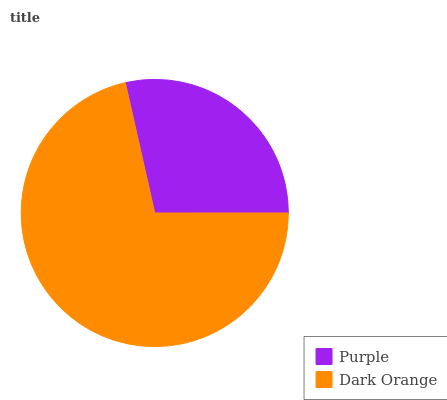Is Purple the minimum?
Answer yes or no. Yes. Is Dark Orange the maximum?
Answer yes or no. Yes. Is Dark Orange the minimum?
Answer yes or no. No. Is Dark Orange greater than Purple?
Answer yes or no. Yes. Is Purple less than Dark Orange?
Answer yes or no. Yes. Is Purple greater than Dark Orange?
Answer yes or no. No. Is Dark Orange less than Purple?
Answer yes or no. No. Is Dark Orange the high median?
Answer yes or no. Yes. Is Purple the low median?
Answer yes or no. Yes. Is Purple the high median?
Answer yes or no. No. Is Dark Orange the low median?
Answer yes or no. No. 